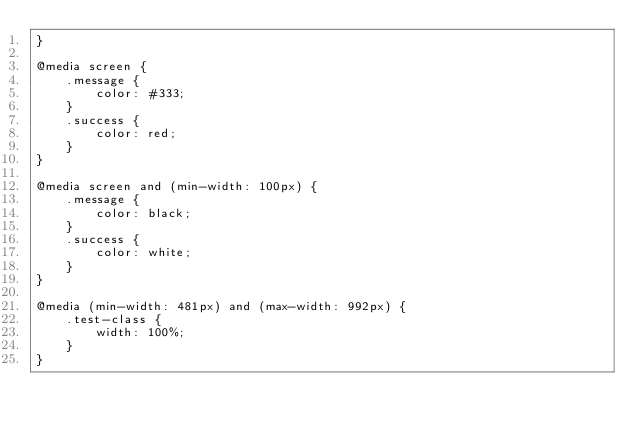<code> <loc_0><loc_0><loc_500><loc_500><_CSS_>}

@media screen {
    .message {
        color: #333;
    }
    .success {
        color: red;
    }
}

@media screen and (min-width: 100px) {
    .message {
        color: black;
    }
    .success {
        color: white;
    }
}

@media (min-width: 481px) and (max-width: 992px) {
    .test-class {
        width: 100%;
    }
}
</code> 